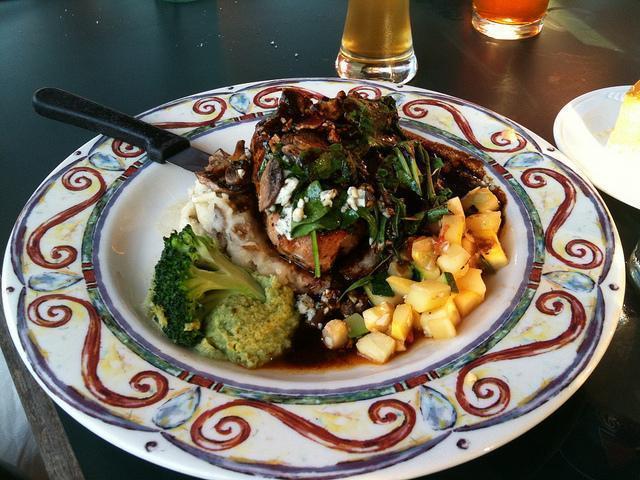What utensil is on the plate?
Choose the right answer from the provided options to respond to the question.
Options: Spoon, chopstick, knife, fork. Knife. 